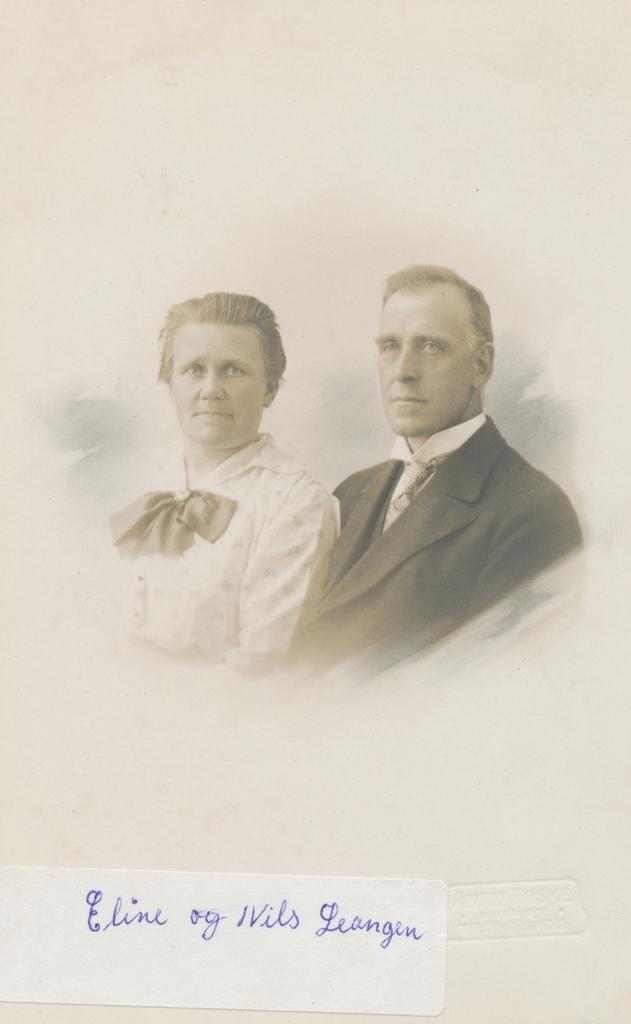How would you summarize this image in a sentence or two? In this image we can see the pictures of man and woman. 